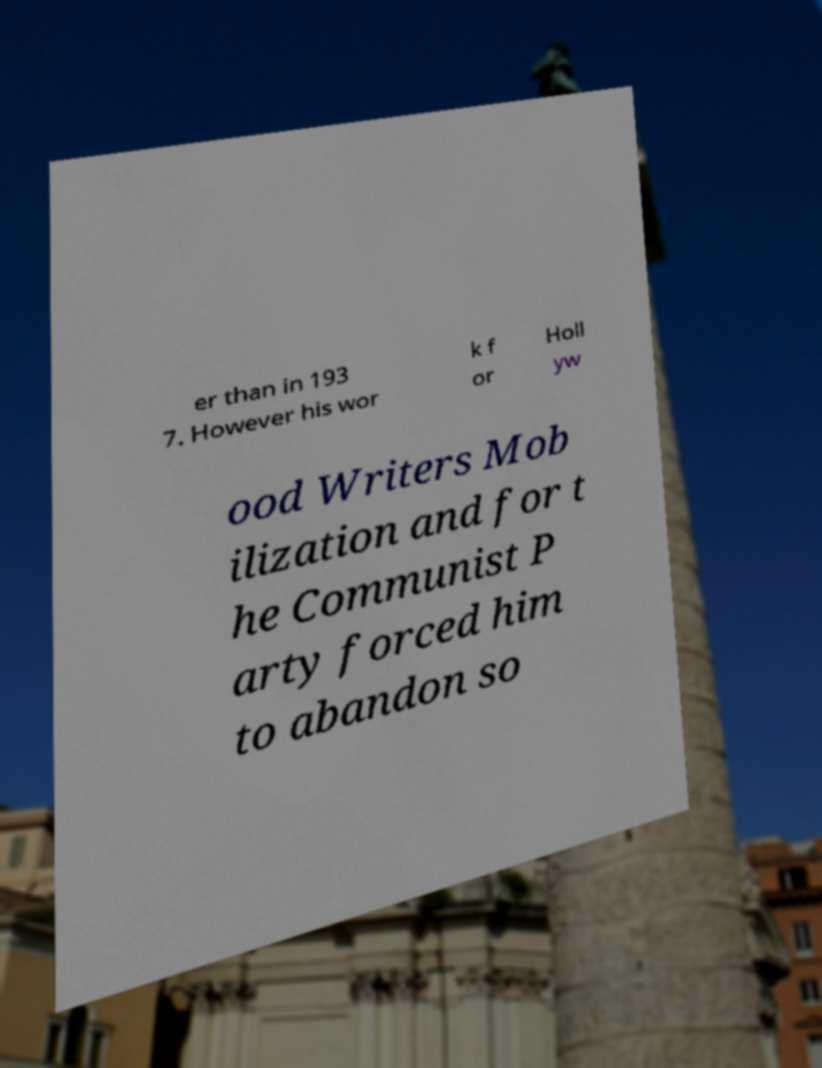Could you extract and type out the text from this image? er than in 193 7. However his wor k f or Holl yw ood Writers Mob ilization and for t he Communist P arty forced him to abandon so 